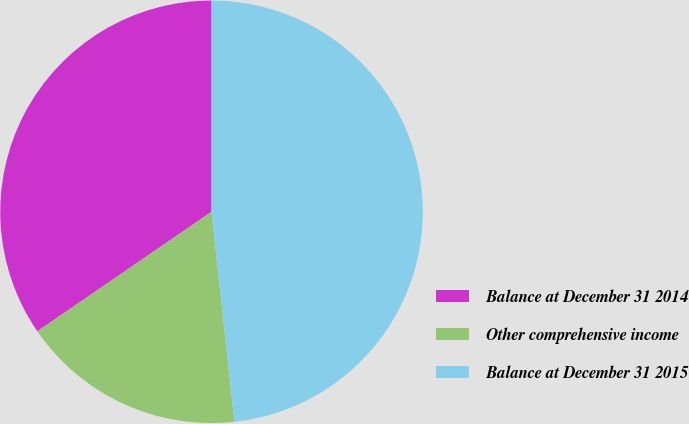Convert chart to OTSL. <chart><loc_0><loc_0><loc_500><loc_500><pie_chart><fcel>Balance at December 31 2014<fcel>Other comprehensive income<fcel>Balance at December 31 2015<nl><fcel>34.57%<fcel>17.16%<fcel>48.27%<nl></chart> 